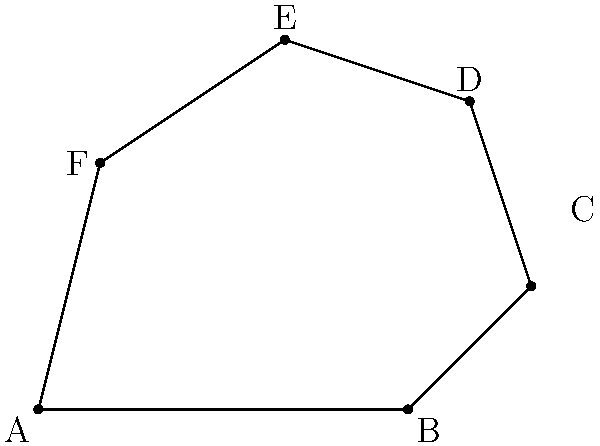As an innovative painter exploring new techniques, you've created an irregularly shaped canvas represented by the polygon ABCDEF shown above. The coordinates of the vertices are A(0,0), B(6,0), C(8,2), D(7,5), E(4,6), and F(1,4). Calculate the area of this unique canvas to determine the amount of primer needed. Express your answer in square units. To calculate the area of this irregular polygon, we can use the Shoelace formula (also known as the surveyor's formula). This method is particularly useful for finding the area of a polygon given the coordinates of its vertices.

The formula is:

$$ \text{Area} = \frac{1}{2}|(x_1y_2 + x_2y_3 + ... + x_ny_1) - (y_1x_2 + y_2x_3 + ... + y_nx_1)| $$

Where $(x_i, y_i)$ are the coordinates of the $i$-th vertex.

Let's apply this formula to our polygon:

1) First, let's list out our coordinates:
   A(0,0), B(6,0), C(8,2), D(7,5), E(4,6), F(1,4)

2) Now, let's calculate the first part of the formula:
   $$(0 \cdot 0 + 6 \cdot 2 + 8 \cdot 5 + 7 \cdot 6 + 4 \cdot 4 + 1 \cdot 0) = 12 + 40 + 42 + 16 = 110$$

3) Next, let's calculate the second part:
   $$(0 \cdot 6 + 0 \cdot 8 + 2 \cdot 7 + 5 \cdot 4 + 6 \cdot 1 + 4 \cdot 0) = 14 + 20 + 6 = 40$$

4) Now, we subtract the second part from the first:
   $$110 - 40 = 70$$

5) Finally, we divide by 2:
   $$\frac{70}{2} = 35$$

Therefore, the area of the irregular canvas is 35 square units.
Answer: 35 square units 